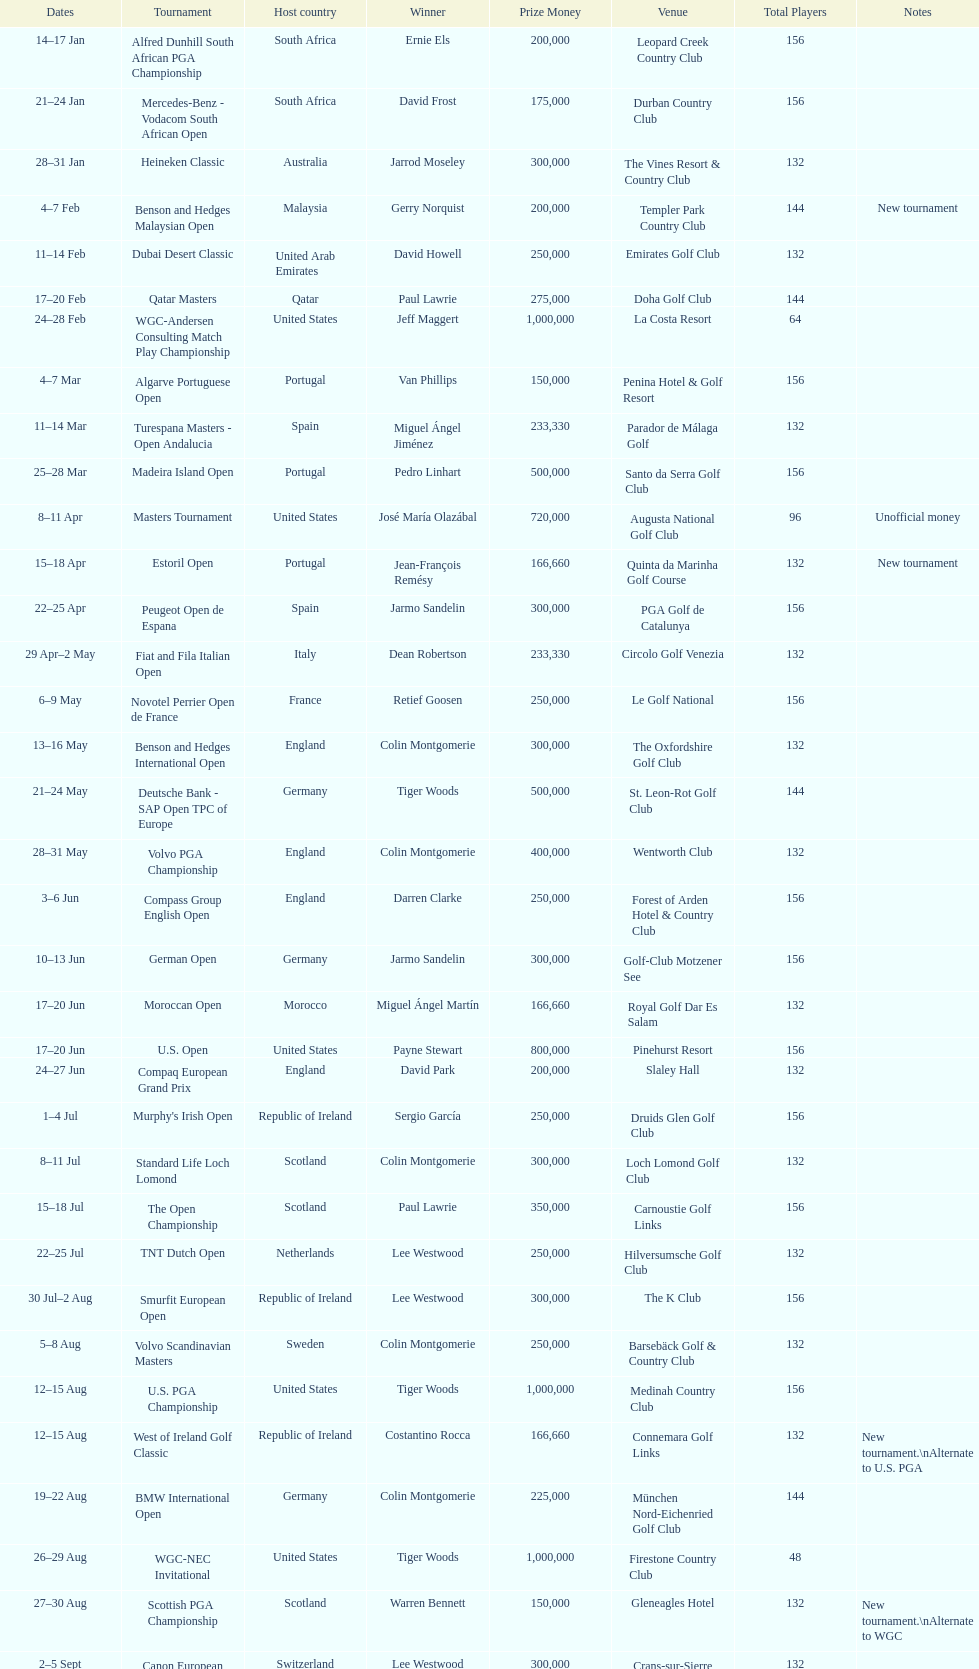Which event took place subsequently, volvo pga or algarve portuguese open? Volvo PGA. 